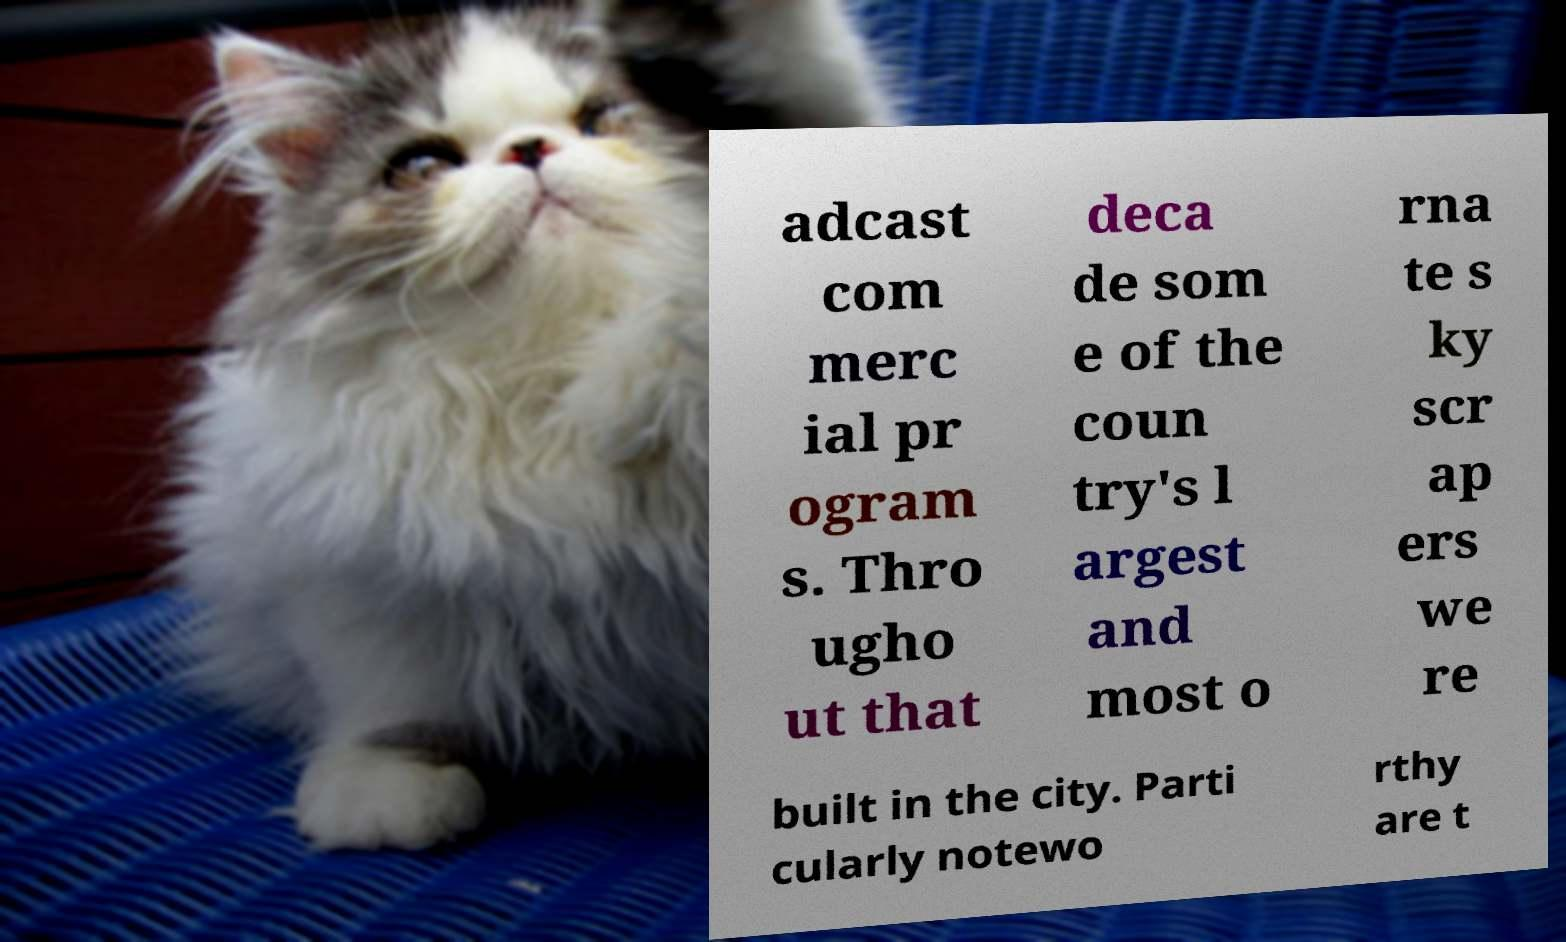Can you accurately transcribe the text from the provided image for me? adcast com merc ial pr ogram s. Thro ugho ut that deca de som e of the coun try's l argest and most o rna te s ky scr ap ers we re built in the city. Parti cularly notewo rthy are t 